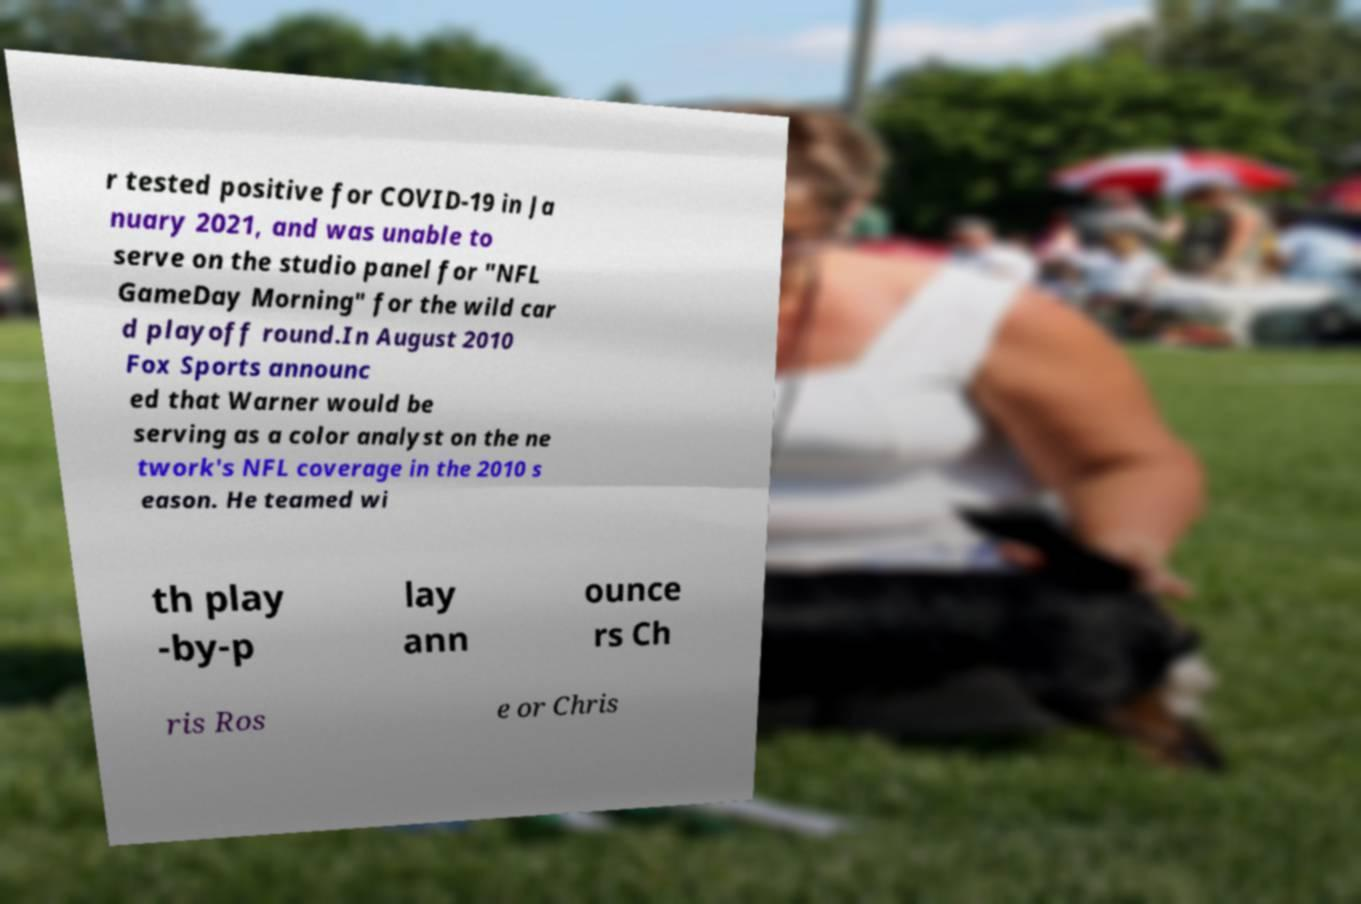Please read and relay the text visible in this image. What does it say? r tested positive for COVID-19 in Ja nuary 2021, and was unable to serve on the studio panel for "NFL GameDay Morning" for the wild car d playoff round.In August 2010 Fox Sports announc ed that Warner would be serving as a color analyst on the ne twork's NFL coverage in the 2010 s eason. He teamed wi th play -by-p lay ann ounce rs Ch ris Ros e or Chris 